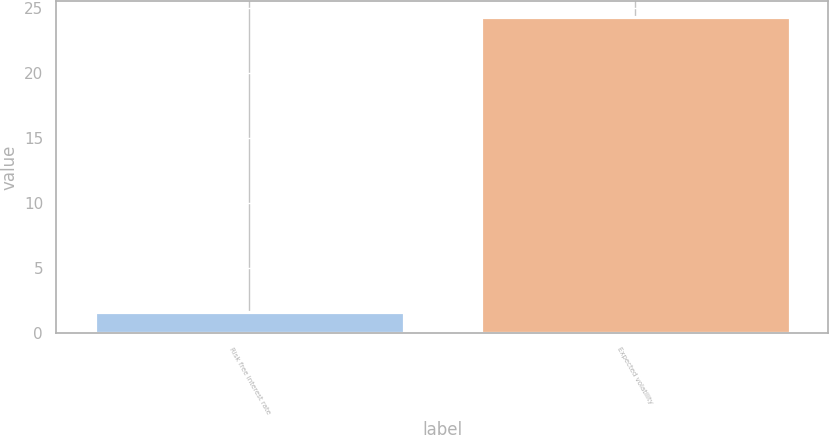Convert chart to OTSL. <chart><loc_0><loc_0><loc_500><loc_500><bar_chart><fcel>Risk free interest rate<fcel>Expected volatility<nl><fcel>1.6<fcel>24.3<nl></chart> 